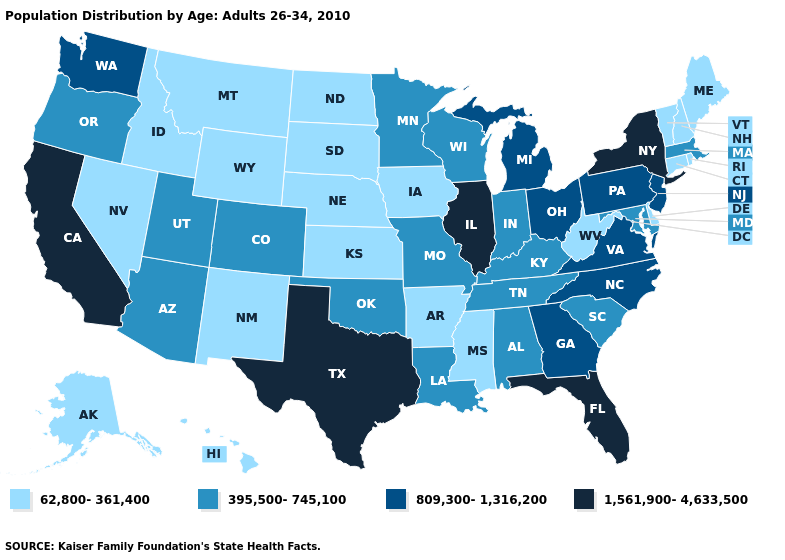Among the states that border Arkansas , which have the highest value?
Concise answer only. Texas. Name the states that have a value in the range 62,800-361,400?
Short answer required. Alaska, Arkansas, Connecticut, Delaware, Hawaii, Idaho, Iowa, Kansas, Maine, Mississippi, Montana, Nebraska, Nevada, New Hampshire, New Mexico, North Dakota, Rhode Island, South Dakota, Vermont, West Virginia, Wyoming. Does the first symbol in the legend represent the smallest category?
Write a very short answer. Yes. Does South Dakota have the highest value in the MidWest?
Answer briefly. No. What is the lowest value in states that border California?
Keep it brief. 62,800-361,400. Name the states that have a value in the range 395,500-745,100?
Concise answer only. Alabama, Arizona, Colorado, Indiana, Kentucky, Louisiana, Maryland, Massachusetts, Minnesota, Missouri, Oklahoma, Oregon, South Carolina, Tennessee, Utah, Wisconsin. Does the map have missing data?
Short answer required. No. What is the highest value in the MidWest ?
Concise answer only. 1,561,900-4,633,500. What is the value of Texas?
Answer briefly. 1,561,900-4,633,500. What is the value of Idaho?
Concise answer only. 62,800-361,400. Does New Hampshire have the lowest value in the Northeast?
Answer briefly. Yes. What is the highest value in states that border Maine?
Short answer required. 62,800-361,400. Among the states that border Rhode Island , which have the lowest value?
Keep it brief. Connecticut. Which states hav the highest value in the Northeast?
Concise answer only. New York. Name the states that have a value in the range 62,800-361,400?
Give a very brief answer. Alaska, Arkansas, Connecticut, Delaware, Hawaii, Idaho, Iowa, Kansas, Maine, Mississippi, Montana, Nebraska, Nevada, New Hampshire, New Mexico, North Dakota, Rhode Island, South Dakota, Vermont, West Virginia, Wyoming. 